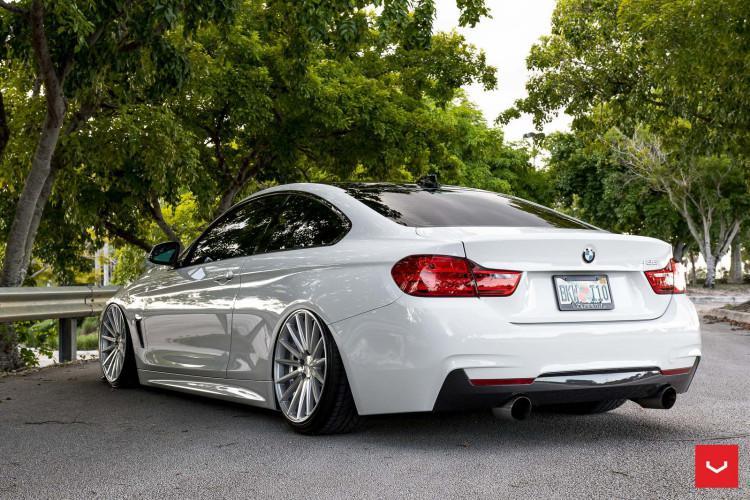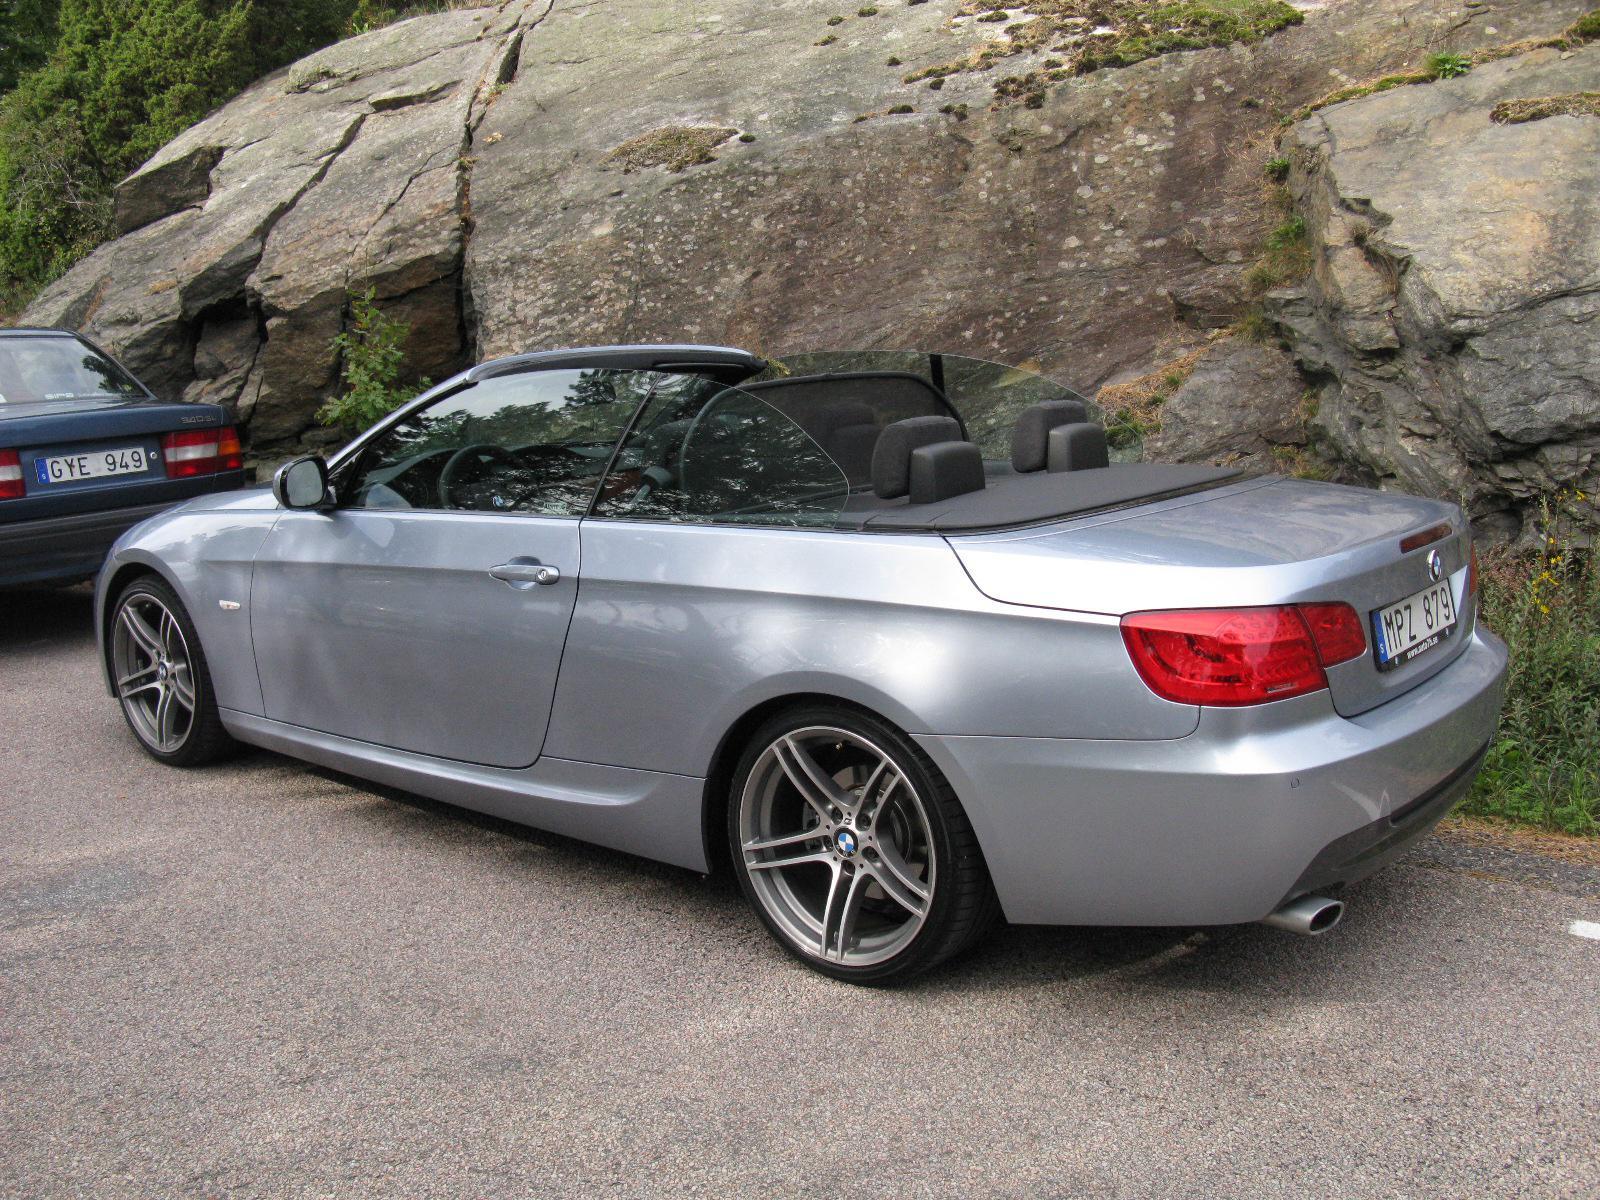The first image is the image on the left, the second image is the image on the right. Considering the images on both sides, is "Two sports cars with chrome wheels and dual exhaust are parked at an angle so that the rear license plate is visible." valid? Answer yes or no. Yes. The first image is the image on the left, the second image is the image on the right. Analyze the images presented: Is the assertion "An image shows a convertible with top down angled rightward, with tailights facing the camera." valid? Answer yes or no. No. 